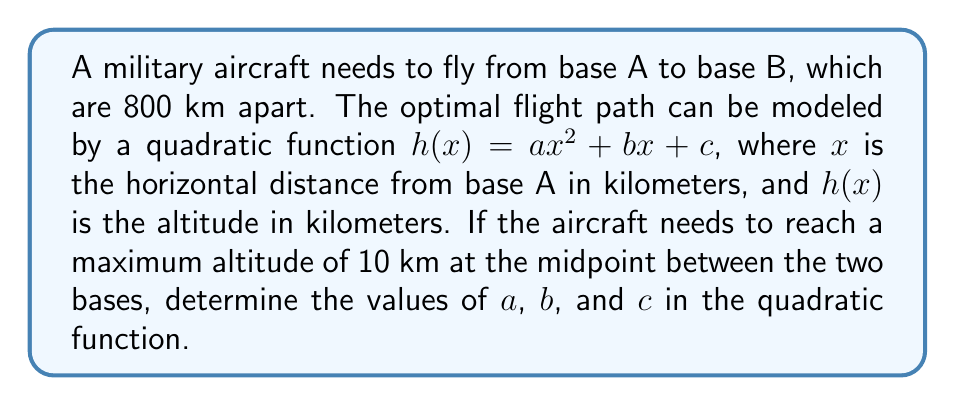Can you answer this question? 1. We know that the aircraft starts and ends at ground level, so:
   $h(0) = 0$ and $h(800) = 0$

2. The maximum altitude of 10 km occurs at the midpoint (400 km):
   $h(400) = 10$

3. Let's use these conditions to set up equations:
   $c = 0$ (since $h(0) = c = 0$)
   $a(800)^2 + b(800) + c = 0$
   $a(400)^2 + b(400) + c = 10$

4. Simplify the equations:
   $640000a + 800b = 0$
   $160000a + 400b = 10$

5. Multiply the second equation by 2:
   $320000a + 800b = 20$

6. Subtract this from the first equation:
   $320000a = -20$
   $a = -\frac{1}{16000} = -0.0000625$

7. Substitute this value of $a$ into $640000a + 800b = 0$:
   $640000(-0.0000625) + 800b = 0$
   $-40 + 800b = 0$
   $800b = 40$
   $b = 0.05$

8. We already know that $c = 0$

Therefore, the quadratic function is:
$h(x) = -0.0000625x^2 + 0.05x$
Answer: $a = -0.0000625$, $b = 0.05$, $c = 0$ 